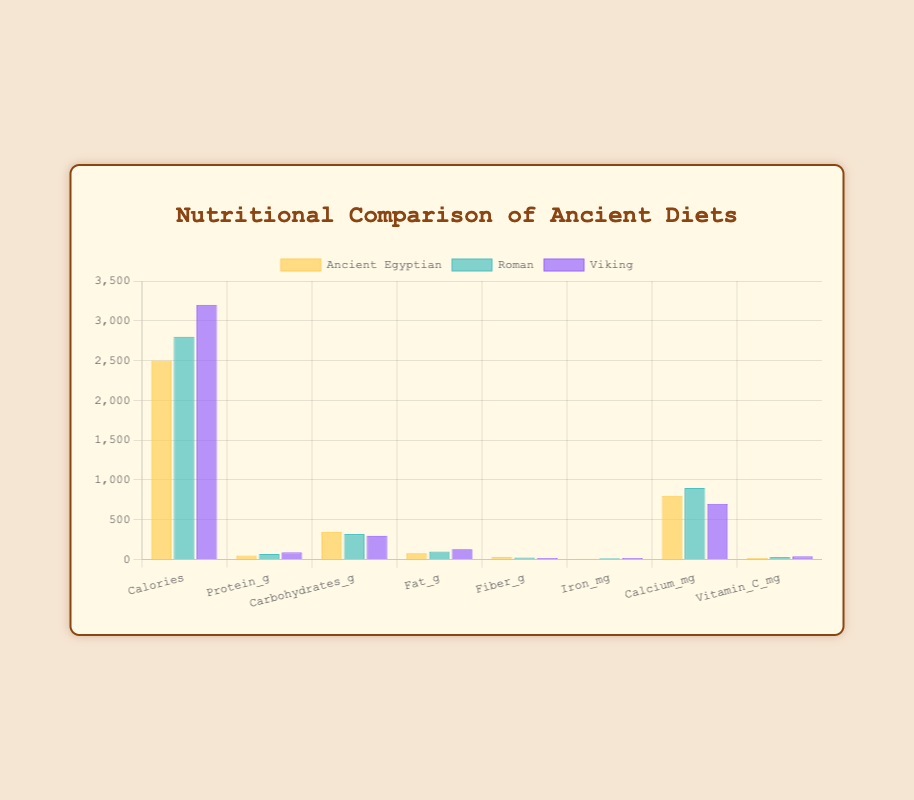How many more grams of protein are consumed in the Viking diet compared to the Ancient Egyptian diet? The Viking diet has 90 grams of protein, while the Ancient Egyptian diet has 50 grams. The difference is 90 - 50.
Answer: 40 grams Which diet has the highest intake of fat? By comparing the fat intake, the calorie values are 80g for Ancient Egyptian, 100g for Roman, and 130g for Viking. The Viking diet has the highest intake.
Answer: Viking What is the total amount of fiber consumed in all three diets combined? Adding the fiber content, we get 30g for Ancient Egyptian, 25g for Roman, and 20g for Viking. The sum is 30 + 25 + 20.
Answer: 75 grams Which diet provides the least amount of iron? The iron content is 10 mg for Ancient Egyptian, 15 mg for Roman, and 20 mg for Viking. The Ancient Egyptian diet provides the least.
Answer: Ancient Egyptian How many more calories are consumed in the Viking diet than in the Roman diet? The Viking diet has 3200 calories, while the Roman diet has 2800 calories. The difference is 3200 - 2800.
Answer: 400 calories Which nutrient in the Roman diet has the maximum value? For the Roman diet, comparing all values, the maximum is the calorie value which is 2800.
Answer: Calories By how much does the calcium intake differ between the Ancient Egyptian and Viking diets? The calcium intake for Ancient Egyptian is 800 mg and for Viking is 700 mg. The difference is 800 - 700.
Answer: 100 mg Which diet has the lowest intake of Vitamin C? Comparing the Vitamin C intake, the values are 20 mg for Ancient Egyptian, 30 mg for Roman, and 40 mg for Viking. The Ancient Egyptian diet has the lowest intake.
Answer: Ancient Egyptian How many grams of carbohydrates are consumed in the combination of Roman and Viking diets? Carbohydrates for Roman is 320g and for Viking is 300g. The combined sum is 320 + 300.
Answer: 620 grams Which diet consumes a higher amount of fiber, Roman or Viking, and by how much? Fiber content is 25g for Roman and 20g for Viking. Roman diet has higher fiber, and the difference is 25 - 20.
Answer: Roman, 5 grams 